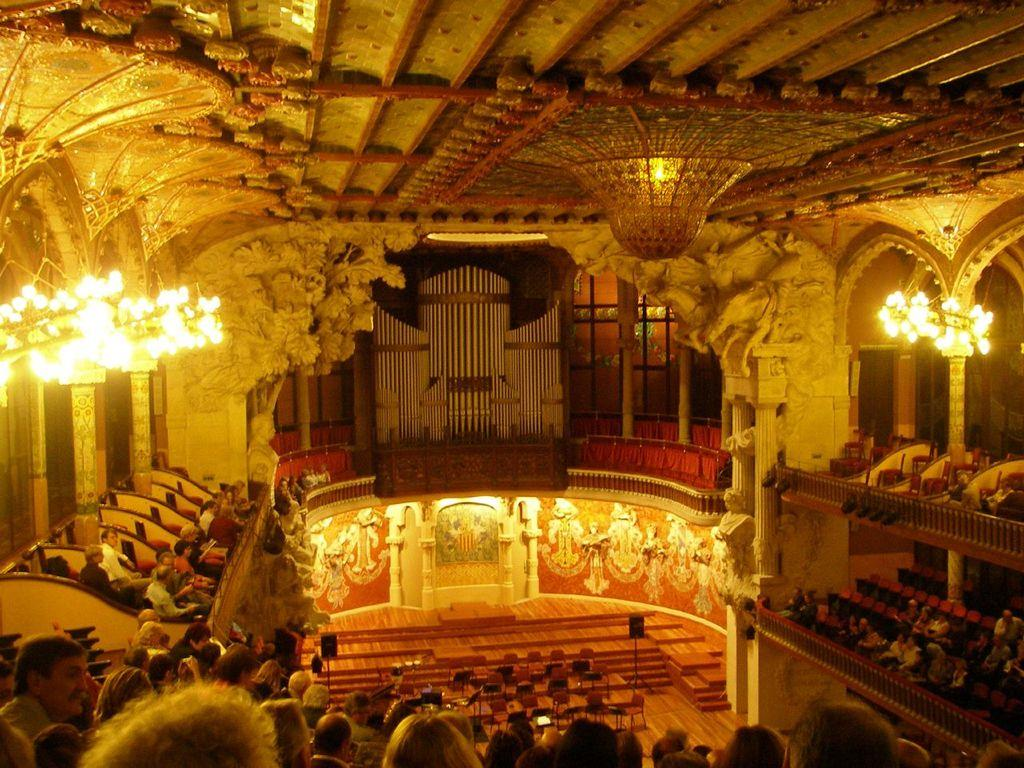What type of location is depicted in the image? The image shows an inside view of a building. Can you describe the people in the image? There is a group of people in the image. What architectural features are present in the image? Pillars are present in the image. What can be seen illuminating the area in the image? Lights are visible in the image. What might be used for amplifying sound in the image? Speakers are present in the image. What other objects can be seen in the image? There are some objects in the image. What part of the building can be seen in the background of the image? There is a roof visible in the background of the image. What type of cub is playing with a vase in the image? There is no cub or vase present in the image. What flavor of cake is being served to the group of people in the image? There is no cake present in the image. 